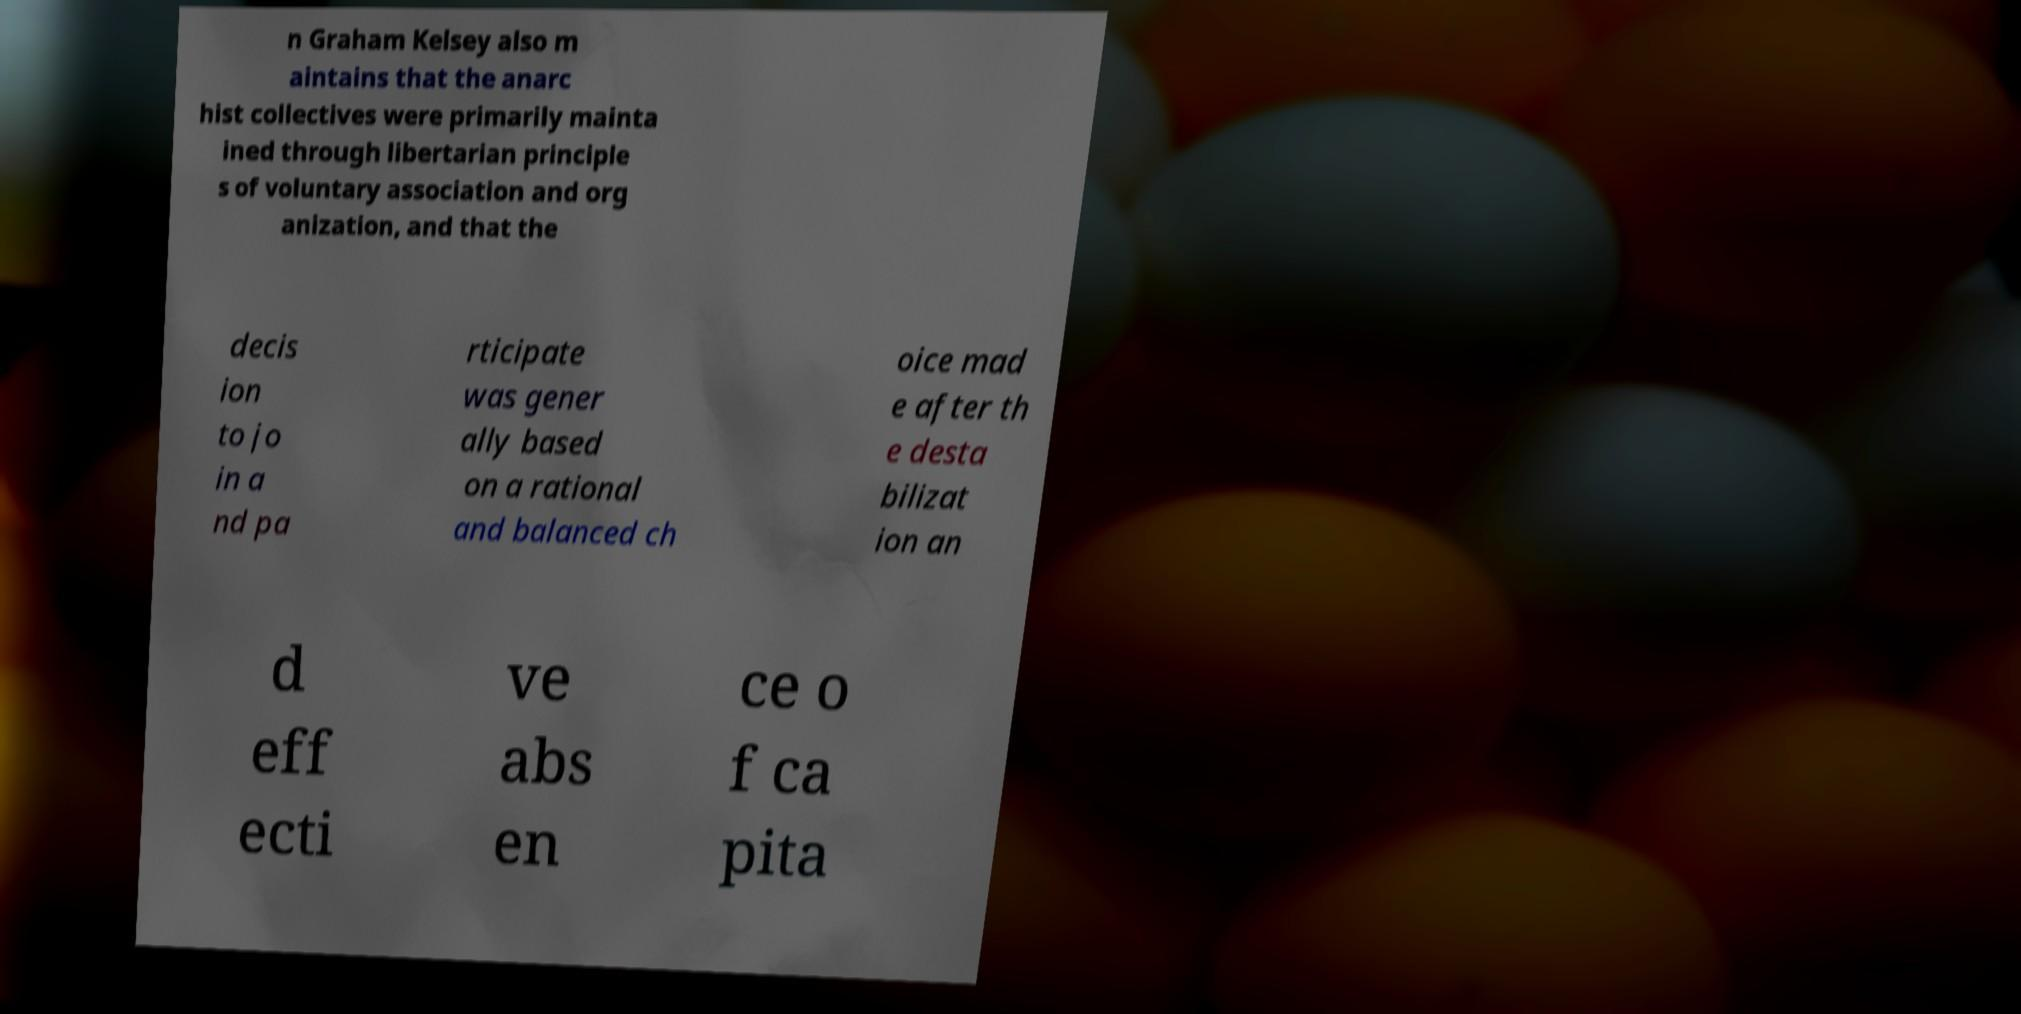Please identify and transcribe the text found in this image. n Graham Kelsey also m aintains that the anarc hist collectives were primarily mainta ined through libertarian principle s of voluntary association and org anization, and that the decis ion to jo in a nd pa rticipate was gener ally based on a rational and balanced ch oice mad e after th e desta bilizat ion an d eff ecti ve abs en ce o f ca pita 